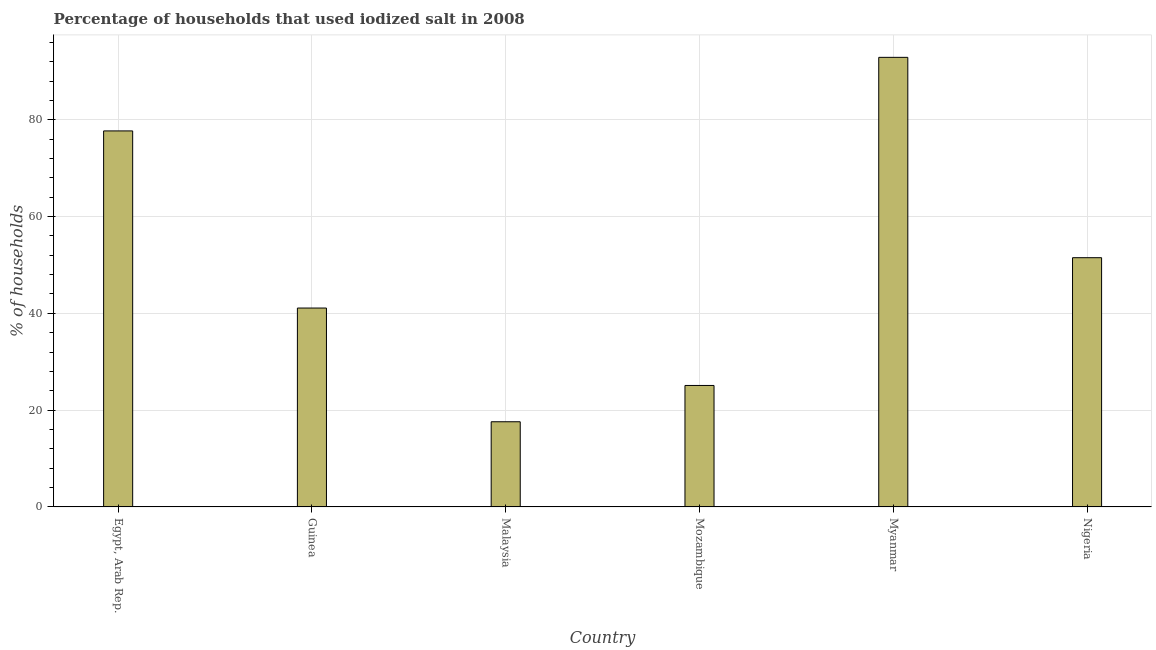Does the graph contain grids?
Your response must be concise. Yes. What is the title of the graph?
Offer a very short reply. Percentage of households that used iodized salt in 2008. What is the label or title of the Y-axis?
Your answer should be very brief. % of households. What is the percentage of households where iodized salt is consumed in Guinea?
Provide a succinct answer. 41.1. Across all countries, what is the maximum percentage of households where iodized salt is consumed?
Your answer should be very brief. 92.9. Across all countries, what is the minimum percentage of households where iodized salt is consumed?
Your response must be concise. 17.6. In which country was the percentage of households where iodized salt is consumed maximum?
Make the answer very short. Myanmar. In which country was the percentage of households where iodized salt is consumed minimum?
Your answer should be compact. Malaysia. What is the sum of the percentage of households where iodized salt is consumed?
Offer a very short reply. 305.9. What is the difference between the percentage of households where iodized salt is consumed in Mozambique and Myanmar?
Make the answer very short. -67.8. What is the average percentage of households where iodized salt is consumed per country?
Make the answer very short. 50.98. What is the median percentage of households where iodized salt is consumed?
Your answer should be very brief. 46.3. In how many countries, is the percentage of households where iodized salt is consumed greater than 40 %?
Provide a succinct answer. 4. What is the ratio of the percentage of households where iodized salt is consumed in Malaysia to that in Nigeria?
Make the answer very short. 0.34. Is the percentage of households where iodized salt is consumed in Guinea less than that in Mozambique?
Your response must be concise. No. Is the difference between the percentage of households where iodized salt is consumed in Egypt, Arab Rep. and Malaysia greater than the difference between any two countries?
Offer a terse response. No. What is the difference between the highest and the second highest percentage of households where iodized salt is consumed?
Your answer should be compact. 15.2. What is the difference between the highest and the lowest percentage of households where iodized salt is consumed?
Make the answer very short. 75.3. In how many countries, is the percentage of households where iodized salt is consumed greater than the average percentage of households where iodized salt is consumed taken over all countries?
Give a very brief answer. 3. What is the difference between two consecutive major ticks on the Y-axis?
Offer a very short reply. 20. Are the values on the major ticks of Y-axis written in scientific E-notation?
Give a very brief answer. No. What is the % of households of Egypt, Arab Rep.?
Keep it short and to the point. 77.7. What is the % of households in Guinea?
Make the answer very short. 41.1. What is the % of households of Mozambique?
Your response must be concise. 25.1. What is the % of households of Myanmar?
Ensure brevity in your answer.  92.9. What is the % of households of Nigeria?
Provide a succinct answer. 51.5. What is the difference between the % of households in Egypt, Arab Rep. and Guinea?
Offer a terse response. 36.6. What is the difference between the % of households in Egypt, Arab Rep. and Malaysia?
Make the answer very short. 60.1. What is the difference between the % of households in Egypt, Arab Rep. and Mozambique?
Your response must be concise. 52.6. What is the difference between the % of households in Egypt, Arab Rep. and Myanmar?
Give a very brief answer. -15.2. What is the difference between the % of households in Egypt, Arab Rep. and Nigeria?
Ensure brevity in your answer.  26.2. What is the difference between the % of households in Guinea and Mozambique?
Offer a very short reply. 16. What is the difference between the % of households in Guinea and Myanmar?
Your response must be concise. -51.8. What is the difference between the % of households in Malaysia and Myanmar?
Provide a succinct answer. -75.3. What is the difference between the % of households in Malaysia and Nigeria?
Your response must be concise. -33.9. What is the difference between the % of households in Mozambique and Myanmar?
Keep it short and to the point. -67.8. What is the difference between the % of households in Mozambique and Nigeria?
Your answer should be compact. -26.4. What is the difference between the % of households in Myanmar and Nigeria?
Give a very brief answer. 41.4. What is the ratio of the % of households in Egypt, Arab Rep. to that in Guinea?
Your answer should be very brief. 1.89. What is the ratio of the % of households in Egypt, Arab Rep. to that in Malaysia?
Offer a very short reply. 4.42. What is the ratio of the % of households in Egypt, Arab Rep. to that in Mozambique?
Provide a succinct answer. 3.1. What is the ratio of the % of households in Egypt, Arab Rep. to that in Myanmar?
Provide a succinct answer. 0.84. What is the ratio of the % of households in Egypt, Arab Rep. to that in Nigeria?
Make the answer very short. 1.51. What is the ratio of the % of households in Guinea to that in Malaysia?
Ensure brevity in your answer.  2.33. What is the ratio of the % of households in Guinea to that in Mozambique?
Your answer should be very brief. 1.64. What is the ratio of the % of households in Guinea to that in Myanmar?
Your answer should be very brief. 0.44. What is the ratio of the % of households in Guinea to that in Nigeria?
Provide a short and direct response. 0.8. What is the ratio of the % of households in Malaysia to that in Mozambique?
Your answer should be compact. 0.7. What is the ratio of the % of households in Malaysia to that in Myanmar?
Offer a very short reply. 0.19. What is the ratio of the % of households in Malaysia to that in Nigeria?
Ensure brevity in your answer.  0.34. What is the ratio of the % of households in Mozambique to that in Myanmar?
Ensure brevity in your answer.  0.27. What is the ratio of the % of households in Mozambique to that in Nigeria?
Your answer should be very brief. 0.49. What is the ratio of the % of households in Myanmar to that in Nigeria?
Provide a short and direct response. 1.8. 